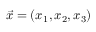Convert formula to latex. <formula><loc_0><loc_0><loc_500><loc_500>\vec { x } = ( x _ { 1 } , x _ { 2 } , x _ { 3 } )</formula> 